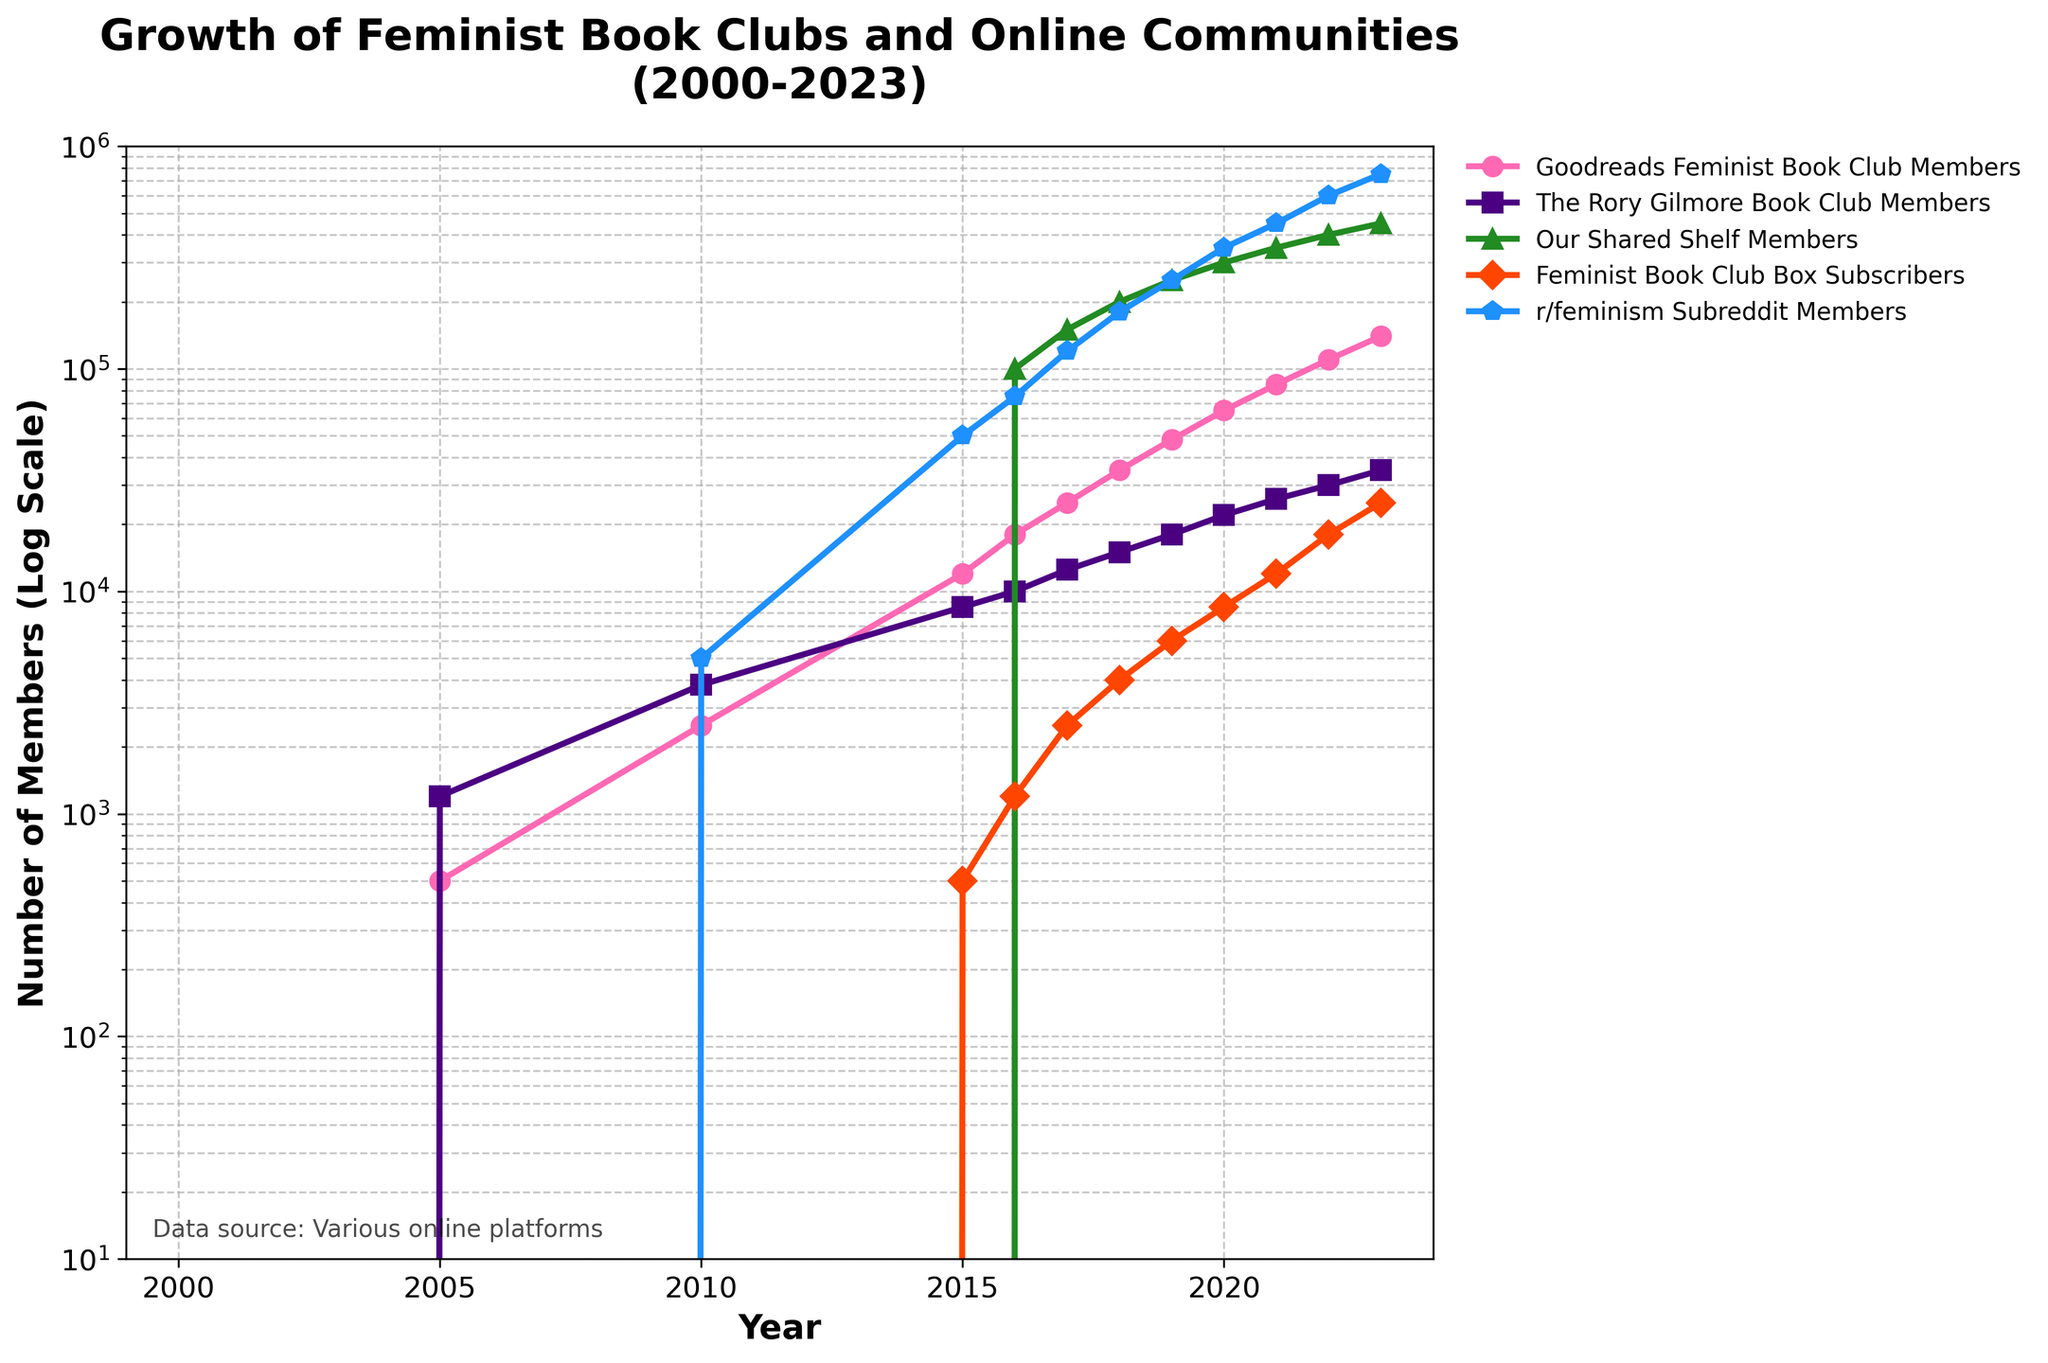What year saw the highest number of Goodreads Feminist Book Club Members? Looking at the line representing the Goodreads Feminist Book Club Members (shown with a specific color and marker), we can see it peaks in 2023 at the highest visible point on the plot.
Answer: 2023 How does the growth of r/feminism Subreddit Members compare between 2019 and 2020? To determine the difference, examine the distance between the markers for r/feminism Subreddit Members in 2019 (250,000 members) and 2020 (350,000 members). The increase is 350,000 - 250,000 = 100,000 members.
Answer: 100,000 members Which community experienced the steepest increase between 2016 and 2017? By comparing the slopes of each line segment between 2016 and 2017, the Our Shared Shelf Members line shows the steepest rise, increasing from 100,000 to 150,000 members.
Answer: Our Shared Shelf Members How many members did the Feminist Book Club Box Subscribers have in 2023 compared to 2015? Check the values for Feminist Book Club Box Subscribers in the respective years: 500 members in 2015 and 25,000 members in 2023. The difference is 25,000 - 500 = 24,500 members.
Answer: 24,500 members What is the total number of members for all communities combined in 2023? Add the values for each community in 2023: 140,000 (Goodreads) + 35,000 (Rory Gilmore) + 450,000 (Our Shared Shelf) + 25,000 (Feminist Book Club Box) + 750,000 (r/feminism) = 1,400,000.
Answer: 1,400,000 Which community showed the first significant growth around 2010 when other communities had little to no growth? Observing the chart around the year 2010, Goodreads Feminist Book Club Members and The Rory Gilmore Book Club Members show noticeable growth compared to other communities.
Answer: Goodreads Feminist Book Club Members and The Rory Gilmore Book Club Members What is the trend of growth for Our Shared Shelf Members from 2016 to 2023? The trend line shows a consistent, steep growth for Our Shared Shelf Members, starting at 100,000 members in 2016 and reaching 450,000 in 2023. This indicates rapid and steady growth over the years.
Answer: Steady, rapid growth Which community had a lower number of members in 2015 compared to the total combined members of all communities in 2005? In 2005, the total combined members = 500 (Goodreads) + 1,200 (Rory Gilmore) = 1,700. In 2015, all communities shown had more members than 1,700, except for Feminist Book Club Box Subscribers, which had 500 members.
Answer: Feminist Book Club Box Subscribers Between which years did the r/feminism Subreddit Members see the largest year-by-year increase? By examining year-to-year differences for r/feminism Subreddit Members, the largest increase is from 2018 (180,000 members) to 2019 (250,000 members), which is a growth of 70,000 members.
Answer: 2018 to 2019 Which community had consistent growth without any decline or plateau during the entire period from 2000 to 2023? Reviewing each community's line on the plot, Our Shared Shelf Members and r/feminism Subreddit Members have consistently increasing lines with no decline or plateau.
Answer: Our Shared Shelf Members and r/feminism Subreddit Members 